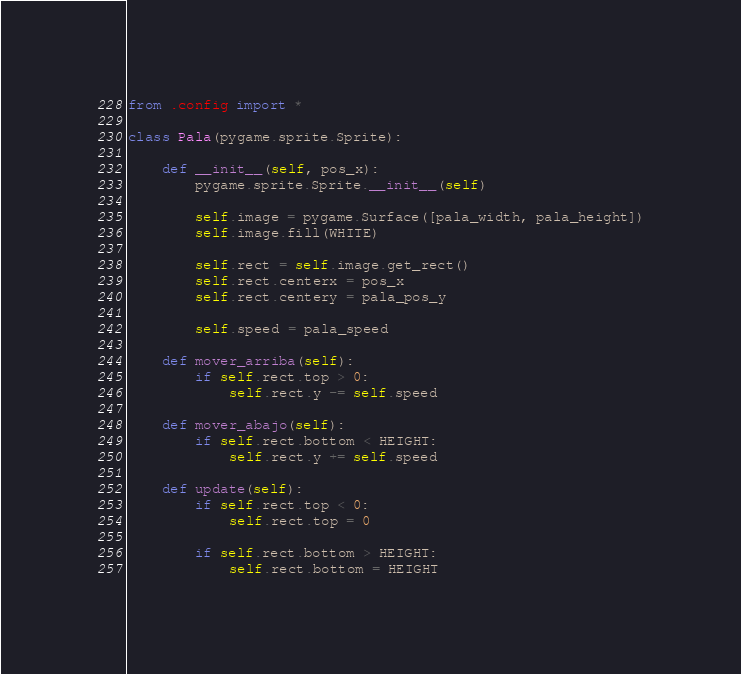Convert code to text. <code><loc_0><loc_0><loc_500><loc_500><_Python_>from .config import *

class Pala(pygame.sprite.Sprite):

	def __init__(self, pos_x):
		pygame.sprite.Sprite.__init__(self)

		self.image = pygame.Surface([pala_width, pala_height])
		self.image.fill(WHITE)

		self.rect = self.image.get_rect()
		self.rect.centerx = pos_x
		self.rect.centery = pala_pos_y

		self.speed = pala_speed

	def mover_arriba(self):
		if self.rect.top > 0:
			self.rect.y -= self.speed

	def mover_abajo(self):
		if self.rect.bottom < HEIGHT:
			self.rect.y += self.speed

	def update(self):
		if self.rect.top < 0:
			self.rect.top = 0

		if self.rect.bottom > HEIGHT:
			self.rect.bottom = HEIGHT
</code> 